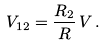<formula> <loc_0><loc_0><loc_500><loc_500>V _ { 1 2 } = \frac { R _ { 2 } } { R } \, V \, .</formula> 